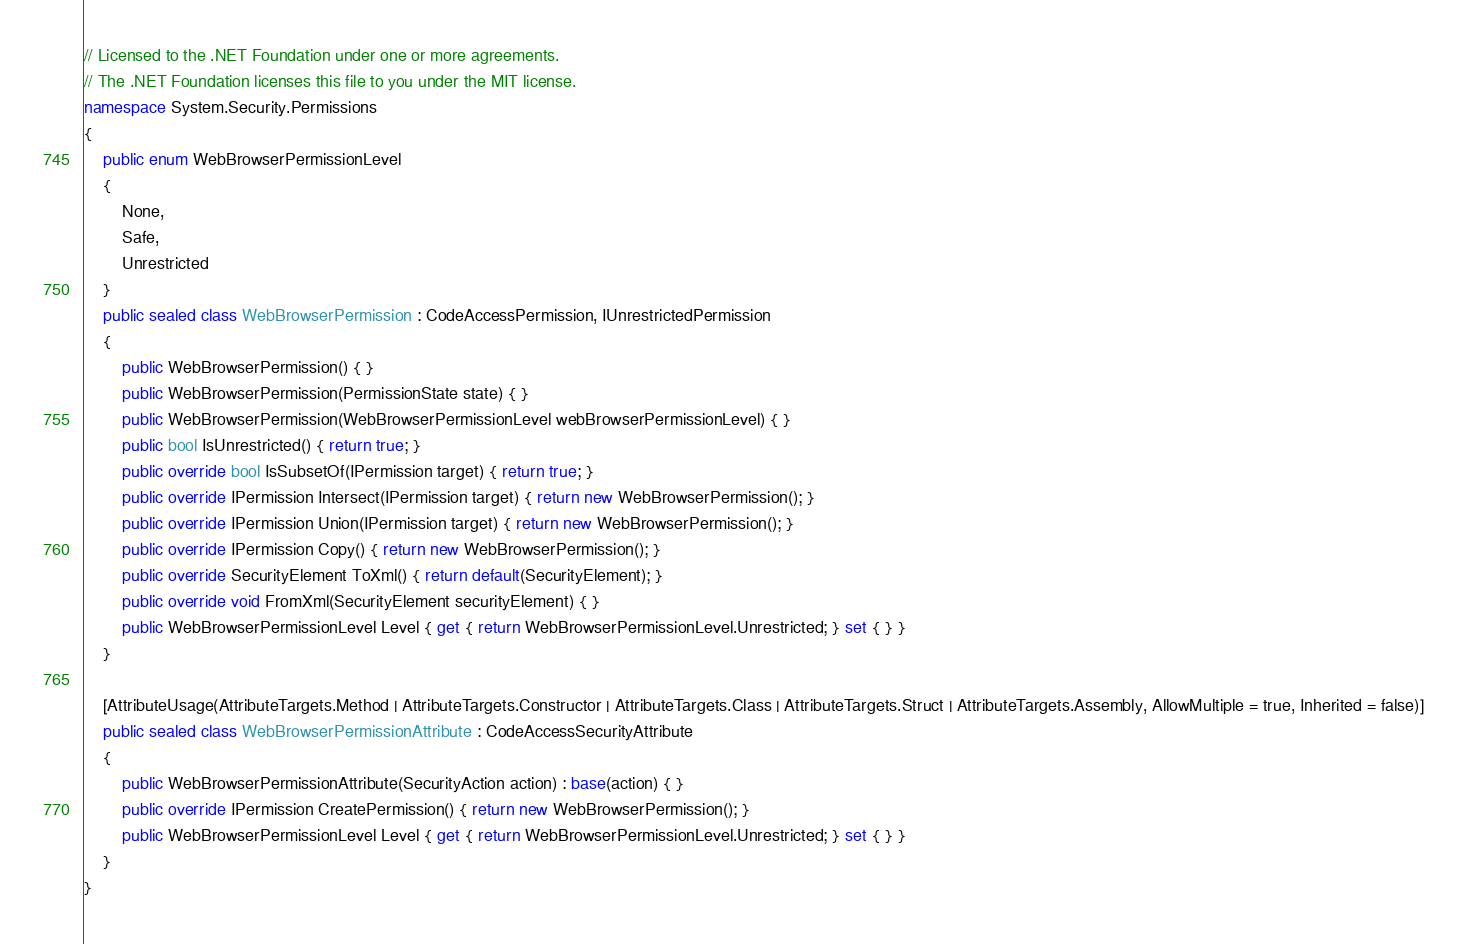<code> <loc_0><loc_0><loc_500><loc_500><_C#_>// Licensed to the .NET Foundation under one or more agreements.
// The .NET Foundation licenses this file to you under the MIT license.
namespace System.Security.Permissions
{
    public enum WebBrowserPermissionLevel
    {
        None,
        Safe,
        Unrestricted
    }
    public sealed class WebBrowserPermission : CodeAccessPermission, IUnrestrictedPermission
    {
        public WebBrowserPermission() { }
        public WebBrowserPermission(PermissionState state) { }
        public WebBrowserPermission(WebBrowserPermissionLevel webBrowserPermissionLevel) { }
        public bool IsUnrestricted() { return true; }
        public override bool IsSubsetOf(IPermission target) { return true; }
        public override IPermission Intersect(IPermission target) { return new WebBrowserPermission(); }
        public override IPermission Union(IPermission target) { return new WebBrowserPermission(); }
        public override IPermission Copy() { return new WebBrowserPermission(); }
        public override SecurityElement ToXml() { return default(SecurityElement); }
        public override void FromXml(SecurityElement securityElement) { }
        public WebBrowserPermissionLevel Level { get { return WebBrowserPermissionLevel.Unrestricted; } set { } }
    }

    [AttributeUsage(AttributeTargets.Method | AttributeTargets.Constructor | AttributeTargets.Class | AttributeTargets.Struct | AttributeTargets.Assembly, AllowMultiple = true, Inherited = false)]
    public sealed class WebBrowserPermissionAttribute : CodeAccessSecurityAttribute
    {
        public WebBrowserPermissionAttribute(SecurityAction action) : base(action) { }
        public override IPermission CreatePermission() { return new WebBrowserPermission(); }
        public WebBrowserPermissionLevel Level { get { return WebBrowserPermissionLevel.Unrestricted; } set { } }
    }
}
</code> 